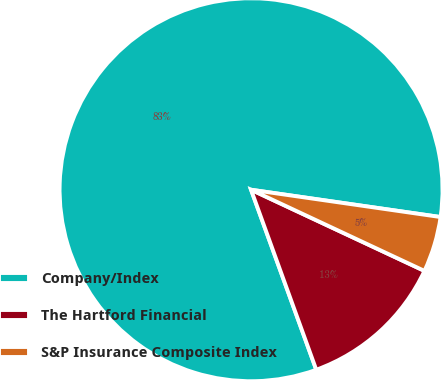Convert chart to OTSL. <chart><loc_0><loc_0><loc_500><loc_500><pie_chart><fcel>Company/Index<fcel>The Hartford Financial<fcel>S&P Insurance Composite Index<nl><fcel>82.8%<fcel>12.5%<fcel>4.69%<nl></chart> 